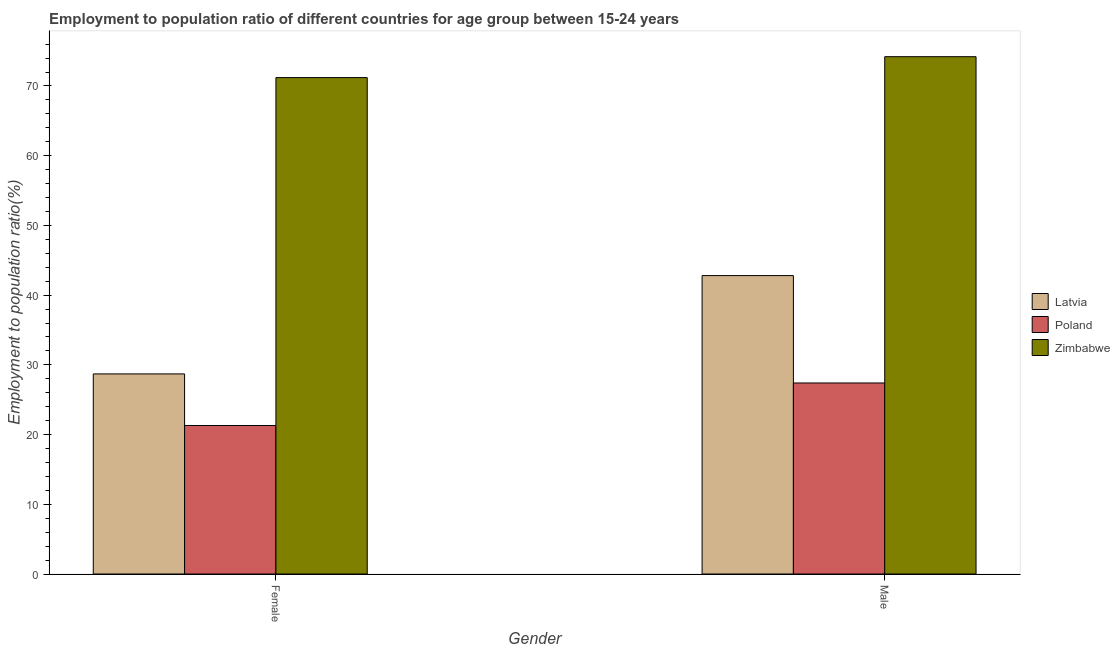Are the number of bars on each tick of the X-axis equal?
Your response must be concise. Yes. What is the employment to population ratio(male) in Poland?
Give a very brief answer. 27.4. Across all countries, what is the maximum employment to population ratio(female)?
Keep it short and to the point. 71.2. Across all countries, what is the minimum employment to population ratio(female)?
Ensure brevity in your answer.  21.3. In which country was the employment to population ratio(female) maximum?
Provide a succinct answer. Zimbabwe. In which country was the employment to population ratio(male) minimum?
Give a very brief answer. Poland. What is the total employment to population ratio(male) in the graph?
Ensure brevity in your answer.  144.4. What is the difference between the employment to population ratio(female) in Latvia and that in Poland?
Offer a terse response. 7.4. What is the difference between the employment to population ratio(male) in Latvia and the employment to population ratio(female) in Zimbabwe?
Your answer should be compact. -28.4. What is the average employment to population ratio(female) per country?
Keep it short and to the point. 40.4. What is the difference between the employment to population ratio(male) and employment to population ratio(female) in Latvia?
Make the answer very short. 14.1. What is the ratio of the employment to population ratio(male) in Poland to that in Zimbabwe?
Offer a very short reply. 0.37. What does the 3rd bar from the left in Male represents?
Ensure brevity in your answer.  Zimbabwe. What does the 1st bar from the right in Male represents?
Your answer should be very brief. Zimbabwe. Are all the bars in the graph horizontal?
Your answer should be compact. No. How many countries are there in the graph?
Your answer should be compact. 3. What is the difference between two consecutive major ticks on the Y-axis?
Your response must be concise. 10. Are the values on the major ticks of Y-axis written in scientific E-notation?
Your response must be concise. No. Does the graph contain grids?
Offer a terse response. No. How many legend labels are there?
Give a very brief answer. 3. What is the title of the graph?
Keep it short and to the point. Employment to population ratio of different countries for age group between 15-24 years. Does "Ecuador" appear as one of the legend labels in the graph?
Your answer should be very brief. No. What is the label or title of the Y-axis?
Make the answer very short. Employment to population ratio(%). What is the Employment to population ratio(%) of Latvia in Female?
Keep it short and to the point. 28.7. What is the Employment to population ratio(%) of Poland in Female?
Ensure brevity in your answer.  21.3. What is the Employment to population ratio(%) in Zimbabwe in Female?
Provide a short and direct response. 71.2. What is the Employment to population ratio(%) in Latvia in Male?
Offer a very short reply. 42.8. What is the Employment to population ratio(%) of Poland in Male?
Provide a succinct answer. 27.4. What is the Employment to population ratio(%) of Zimbabwe in Male?
Give a very brief answer. 74.2. Across all Gender, what is the maximum Employment to population ratio(%) in Latvia?
Provide a succinct answer. 42.8. Across all Gender, what is the maximum Employment to population ratio(%) of Poland?
Make the answer very short. 27.4. Across all Gender, what is the maximum Employment to population ratio(%) in Zimbabwe?
Offer a very short reply. 74.2. Across all Gender, what is the minimum Employment to population ratio(%) in Latvia?
Provide a succinct answer. 28.7. Across all Gender, what is the minimum Employment to population ratio(%) of Poland?
Offer a terse response. 21.3. Across all Gender, what is the minimum Employment to population ratio(%) of Zimbabwe?
Keep it short and to the point. 71.2. What is the total Employment to population ratio(%) of Latvia in the graph?
Give a very brief answer. 71.5. What is the total Employment to population ratio(%) in Poland in the graph?
Give a very brief answer. 48.7. What is the total Employment to population ratio(%) of Zimbabwe in the graph?
Offer a very short reply. 145.4. What is the difference between the Employment to population ratio(%) in Latvia in Female and that in Male?
Offer a terse response. -14.1. What is the difference between the Employment to population ratio(%) of Zimbabwe in Female and that in Male?
Your answer should be compact. -3. What is the difference between the Employment to population ratio(%) of Latvia in Female and the Employment to population ratio(%) of Zimbabwe in Male?
Your response must be concise. -45.5. What is the difference between the Employment to population ratio(%) of Poland in Female and the Employment to population ratio(%) of Zimbabwe in Male?
Ensure brevity in your answer.  -52.9. What is the average Employment to population ratio(%) in Latvia per Gender?
Make the answer very short. 35.75. What is the average Employment to population ratio(%) in Poland per Gender?
Offer a very short reply. 24.35. What is the average Employment to population ratio(%) of Zimbabwe per Gender?
Offer a terse response. 72.7. What is the difference between the Employment to population ratio(%) in Latvia and Employment to population ratio(%) in Poland in Female?
Keep it short and to the point. 7.4. What is the difference between the Employment to population ratio(%) of Latvia and Employment to population ratio(%) of Zimbabwe in Female?
Offer a very short reply. -42.5. What is the difference between the Employment to population ratio(%) in Poland and Employment to population ratio(%) in Zimbabwe in Female?
Your response must be concise. -49.9. What is the difference between the Employment to population ratio(%) of Latvia and Employment to population ratio(%) of Poland in Male?
Offer a terse response. 15.4. What is the difference between the Employment to population ratio(%) in Latvia and Employment to population ratio(%) in Zimbabwe in Male?
Provide a short and direct response. -31.4. What is the difference between the Employment to population ratio(%) in Poland and Employment to population ratio(%) in Zimbabwe in Male?
Your response must be concise. -46.8. What is the ratio of the Employment to population ratio(%) in Latvia in Female to that in Male?
Offer a very short reply. 0.67. What is the ratio of the Employment to population ratio(%) in Poland in Female to that in Male?
Your response must be concise. 0.78. What is the ratio of the Employment to population ratio(%) in Zimbabwe in Female to that in Male?
Give a very brief answer. 0.96. What is the difference between the highest and the second highest Employment to population ratio(%) of Latvia?
Make the answer very short. 14.1. What is the difference between the highest and the second highest Employment to population ratio(%) in Poland?
Ensure brevity in your answer.  6.1. What is the difference between the highest and the second highest Employment to population ratio(%) in Zimbabwe?
Your response must be concise. 3. What is the difference between the highest and the lowest Employment to population ratio(%) of Latvia?
Make the answer very short. 14.1. 